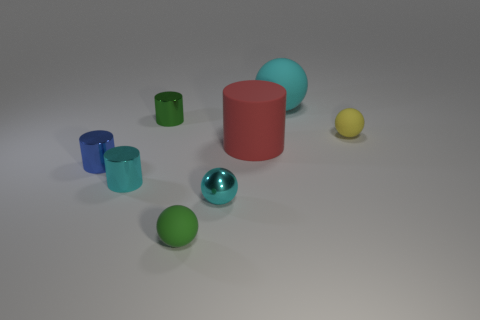Subtract all small green balls. How many balls are left? 3 Subtract 1 cylinders. How many cylinders are left? 3 Add 1 small purple balls. How many objects exist? 9 Subtract all purple spheres. Subtract all cyan cylinders. How many spheres are left? 4 Subtract all tiny purple shiny objects. Subtract all large red matte things. How many objects are left? 7 Add 5 cylinders. How many cylinders are left? 9 Add 7 small metallic balls. How many small metallic balls exist? 8 Subtract 0 gray cubes. How many objects are left? 8 